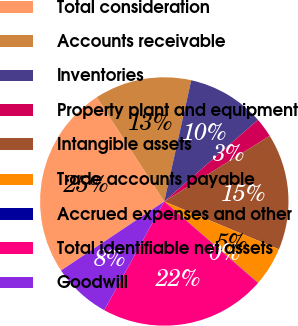Convert chart to OTSL. <chart><loc_0><loc_0><loc_500><loc_500><pie_chart><fcel>Total consideration<fcel>Accounts receivable<fcel>Inventories<fcel>Property plant and equipment<fcel>Intangible assets<fcel>Trade accounts payable<fcel>Accrued expenses and other<fcel>Total identifiable net assets<fcel>Goodwill<nl><fcel>25.23%<fcel>12.63%<fcel>10.11%<fcel>2.55%<fcel>15.15%<fcel>5.07%<fcel>0.04%<fcel>21.62%<fcel>7.59%<nl></chart> 